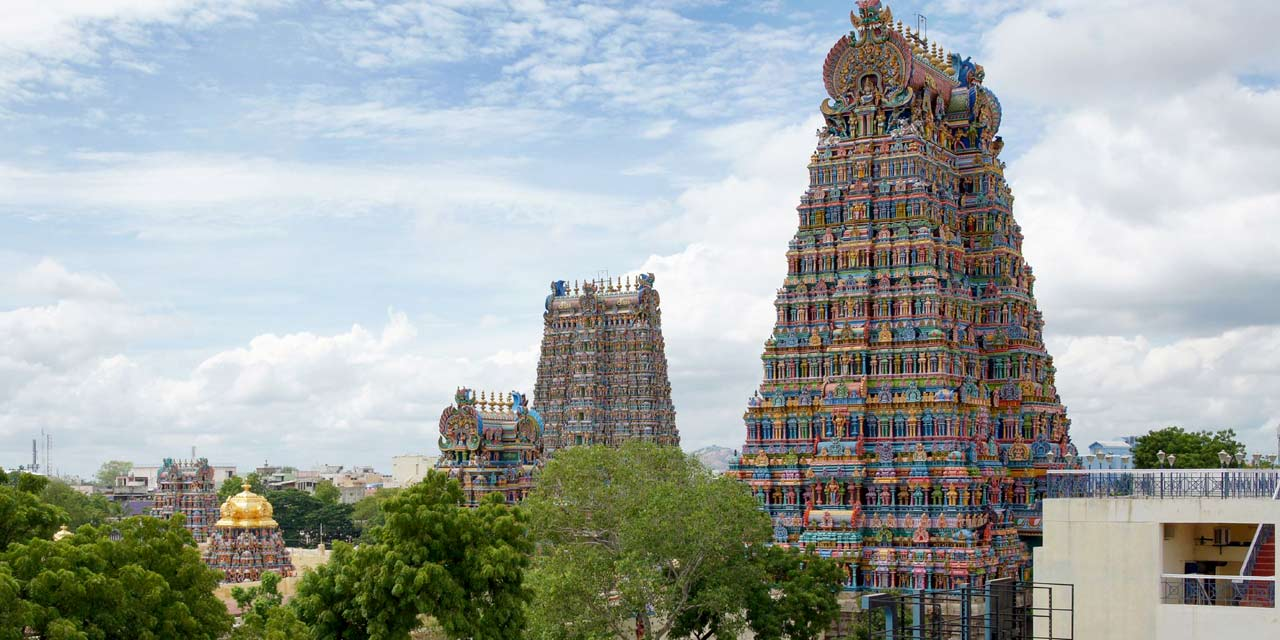What cultural significance does this temple hold? The Meenakshi Amman Temple holds immense cultural and religious significance in Hindu tradition. It is dedicated to Goddess Meenakshi, an avatar of Parvati, and her consort, Lord Sundareswarar, an avatar of Shiva. The temple is not just a place of worship but also a cultural hub, hosting numerous festivals, the most important of which is the Meenakshi Thirukalyanam, celebrating the divine marriage of Meenakshi and Sundareswarar. This event attracts thousands of pilgrims and visitors from all over the world, reflecting the temple's deep-rooted cultural importance. Additionally, the temple's architecture and art serve as a repository of Tamil culture and history, showcasing the region's artistic brilliance and religious devotion. 